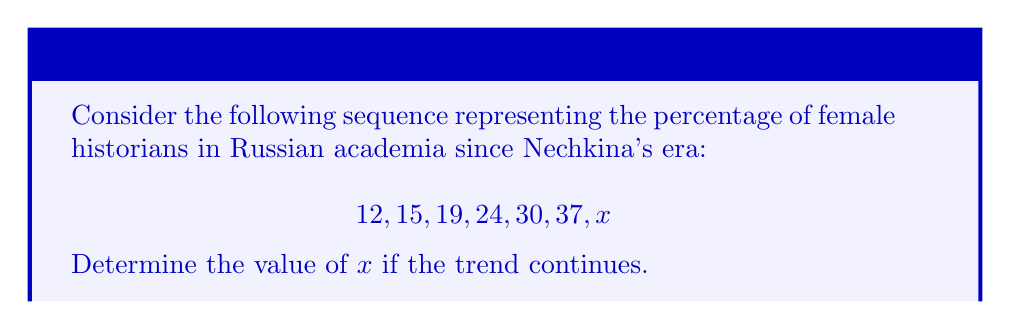Can you solve this math problem? To solve this problem, we need to analyze the pattern in the given sequence:

1) First, calculate the differences between consecutive terms:
   $15 - 12 = 3$
   $19 - 15 = 4$
   $24 - 19 = 5$
   $30 - 24 = 6$
   $37 - 30 = 7$

2) We observe that the differences form an arithmetic sequence: 3, 4, 5, 6, 7

3) The common difference of this arithmetic sequence is 1

4) Therefore, the next difference should be 8

5) To find $x$, we add this difference to the last given term:
   $x = 37 + 8 = 45$

This trend suggests a steady increase in the percentage of female historians in Russian academia since Nechkina's era, with the rate of increase accelerating over time.
Answer: $x = 45$ 